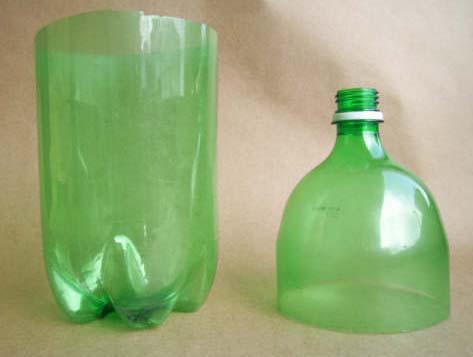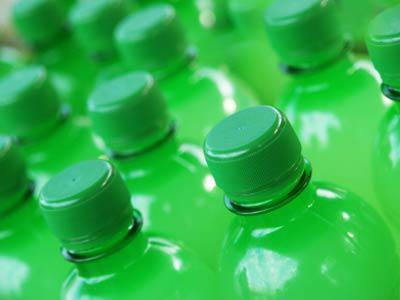The first image is the image on the left, the second image is the image on the right. Assess this claim about the two images: "The top of the bottle is sitting next to the bottom in one of the images.". Correct or not? Answer yes or no. Yes. The first image is the image on the left, the second image is the image on the right. For the images shown, is this caption "In at least one image there is a green soda bottle cut in to two pieces." true? Answer yes or no. Yes. 